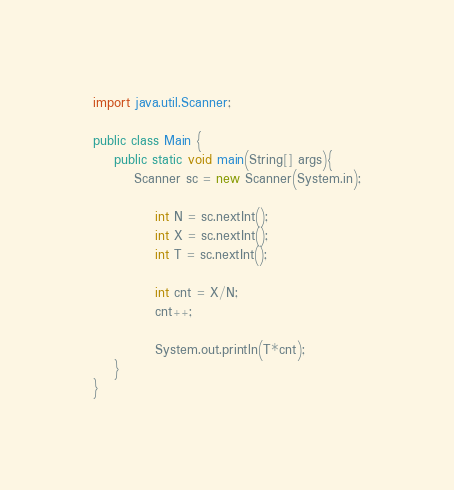<code> <loc_0><loc_0><loc_500><loc_500><_Java_>
import java.util.Scanner;

public class Main {
	public static void main(String[] args){
		Scanner sc = new Scanner(System.in);
			
			int N = sc.nextInt();
			int X = sc.nextInt();
			int T = sc.nextInt();
			
			int cnt = X/N;
			cnt++;
			
			System.out.println(T*cnt);
	}	
}</code> 